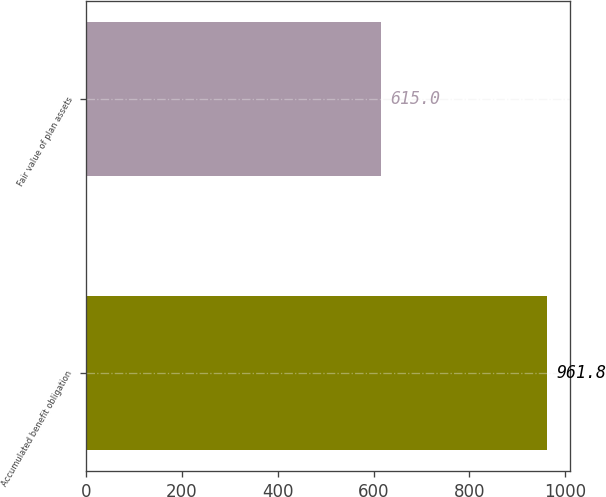<chart> <loc_0><loc_0><loc_500><loc_500><bar_chart><fcel>Accumulated benefit obligation<fcel>Fair value of plan assets<nl><fcel>961.8<fcel>615<nl></chart> 